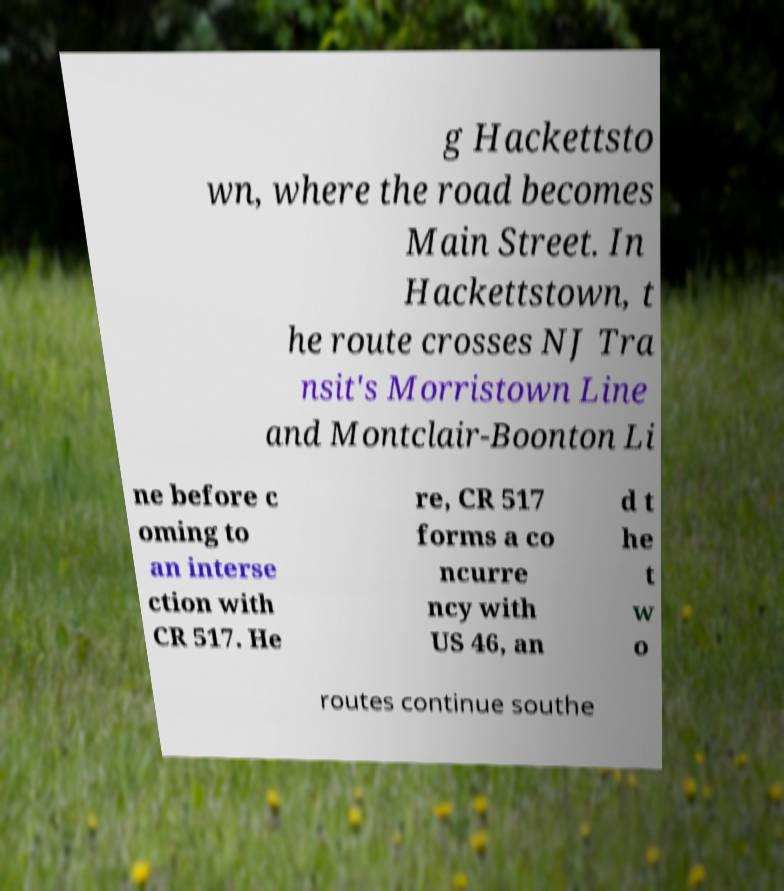Can you read and provide the text displayed in the image?This photo seems to have some interesting text. Can you extract and type it out for me? g Hackettsto wn, where the road becomes Main Street. In Hackettstown, t he route crosses NJ Tra nsit's Morristown Line and Montclair-Boonton Li ne before c oming to an interse ction with CR 517. He re, CR 517 forms a co ncurre ncy with US 46, an d t he t w o routes continue southe 